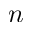Convert formula to latex. <formula><loc_0><loc_0><loc_500><loc_500>n</formula> 